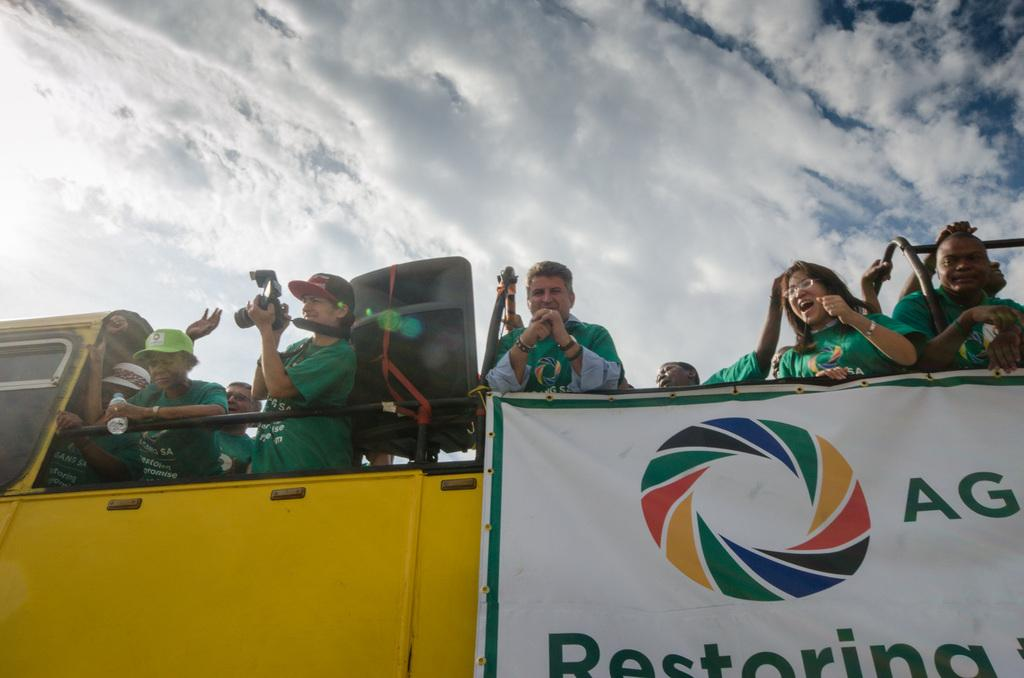What are the people in the image doing? The people in the image are standing in a vehicle. What else can be seen in the image besides the people? There is a poster in the image. What is visible in the background of the image? The sky is visible in the image. What is the condition of the sky in the image? The sky is cloudy in the image. What type of guitar can be seen in the image? There is no guitar present in the image. What reason did the people have for standing in the vehicle in the image? The image does not provide any information about the reason for the people standing in the vehicle. 